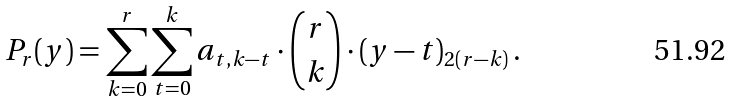<formula> <loc_0><loc_0><loc_500><loc_500>P _ { r } ( y ) = \sum _ { k = 0 } ^ { r } \sum _ { t = 0 } ^ { k } a _ { t , k - t } \cdot \binom { r } { k } \cdot ( y - t ) _ { 2 ( r - k ) } \, .</formula> 